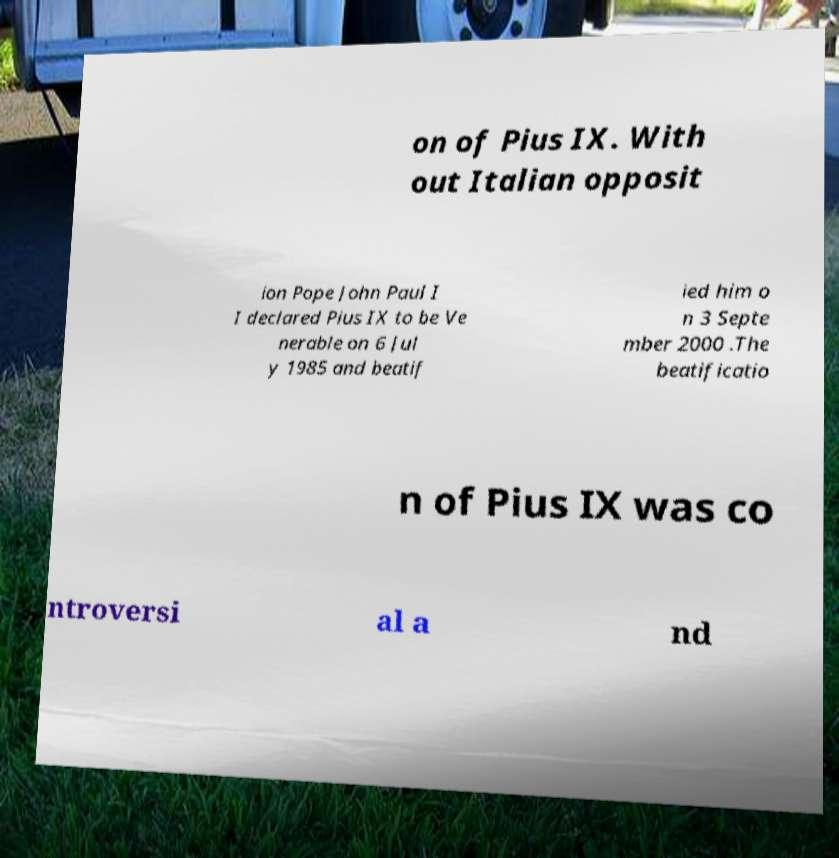Could you extract and type out the text from this image? on of Pius IX. With out Italian opposit ion Pope John Paul I I declared Pius IX to be Ve nerable on 6 Jul y 1985 and beatif ied him o n 3 Septe mber 2000 .The beatificatio n of Pius IX was co ntroversi al a nd 